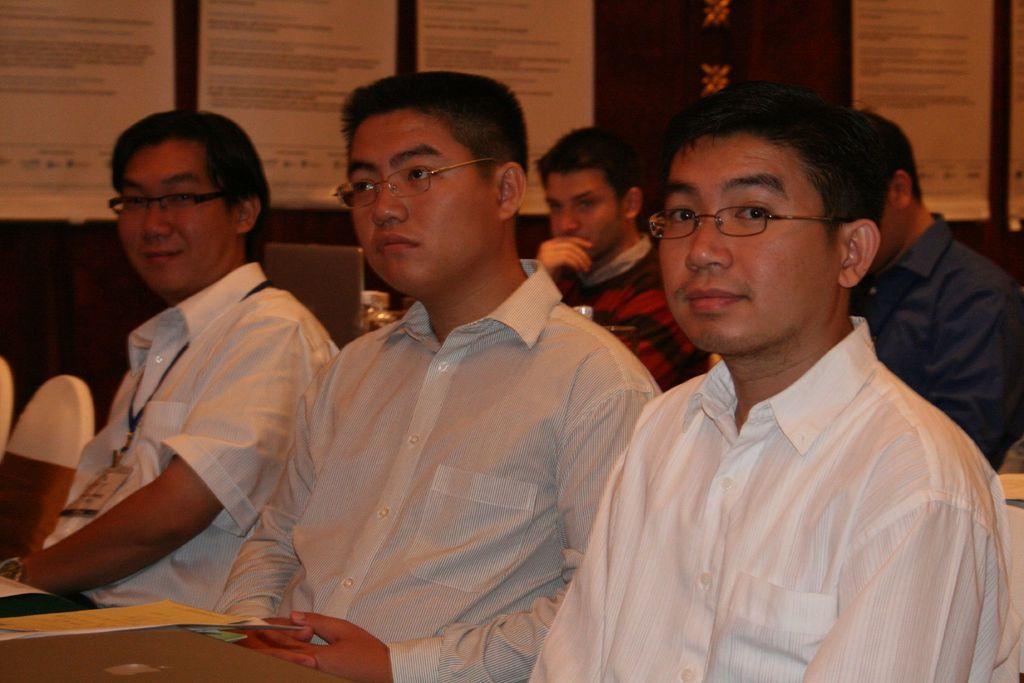Please provide a concise description of this image. In this image I can see people sitting on the chairs. 3 people sitting in the front are wearing white shirts and spectacles. There is a laptop and papers are attached at the back. 